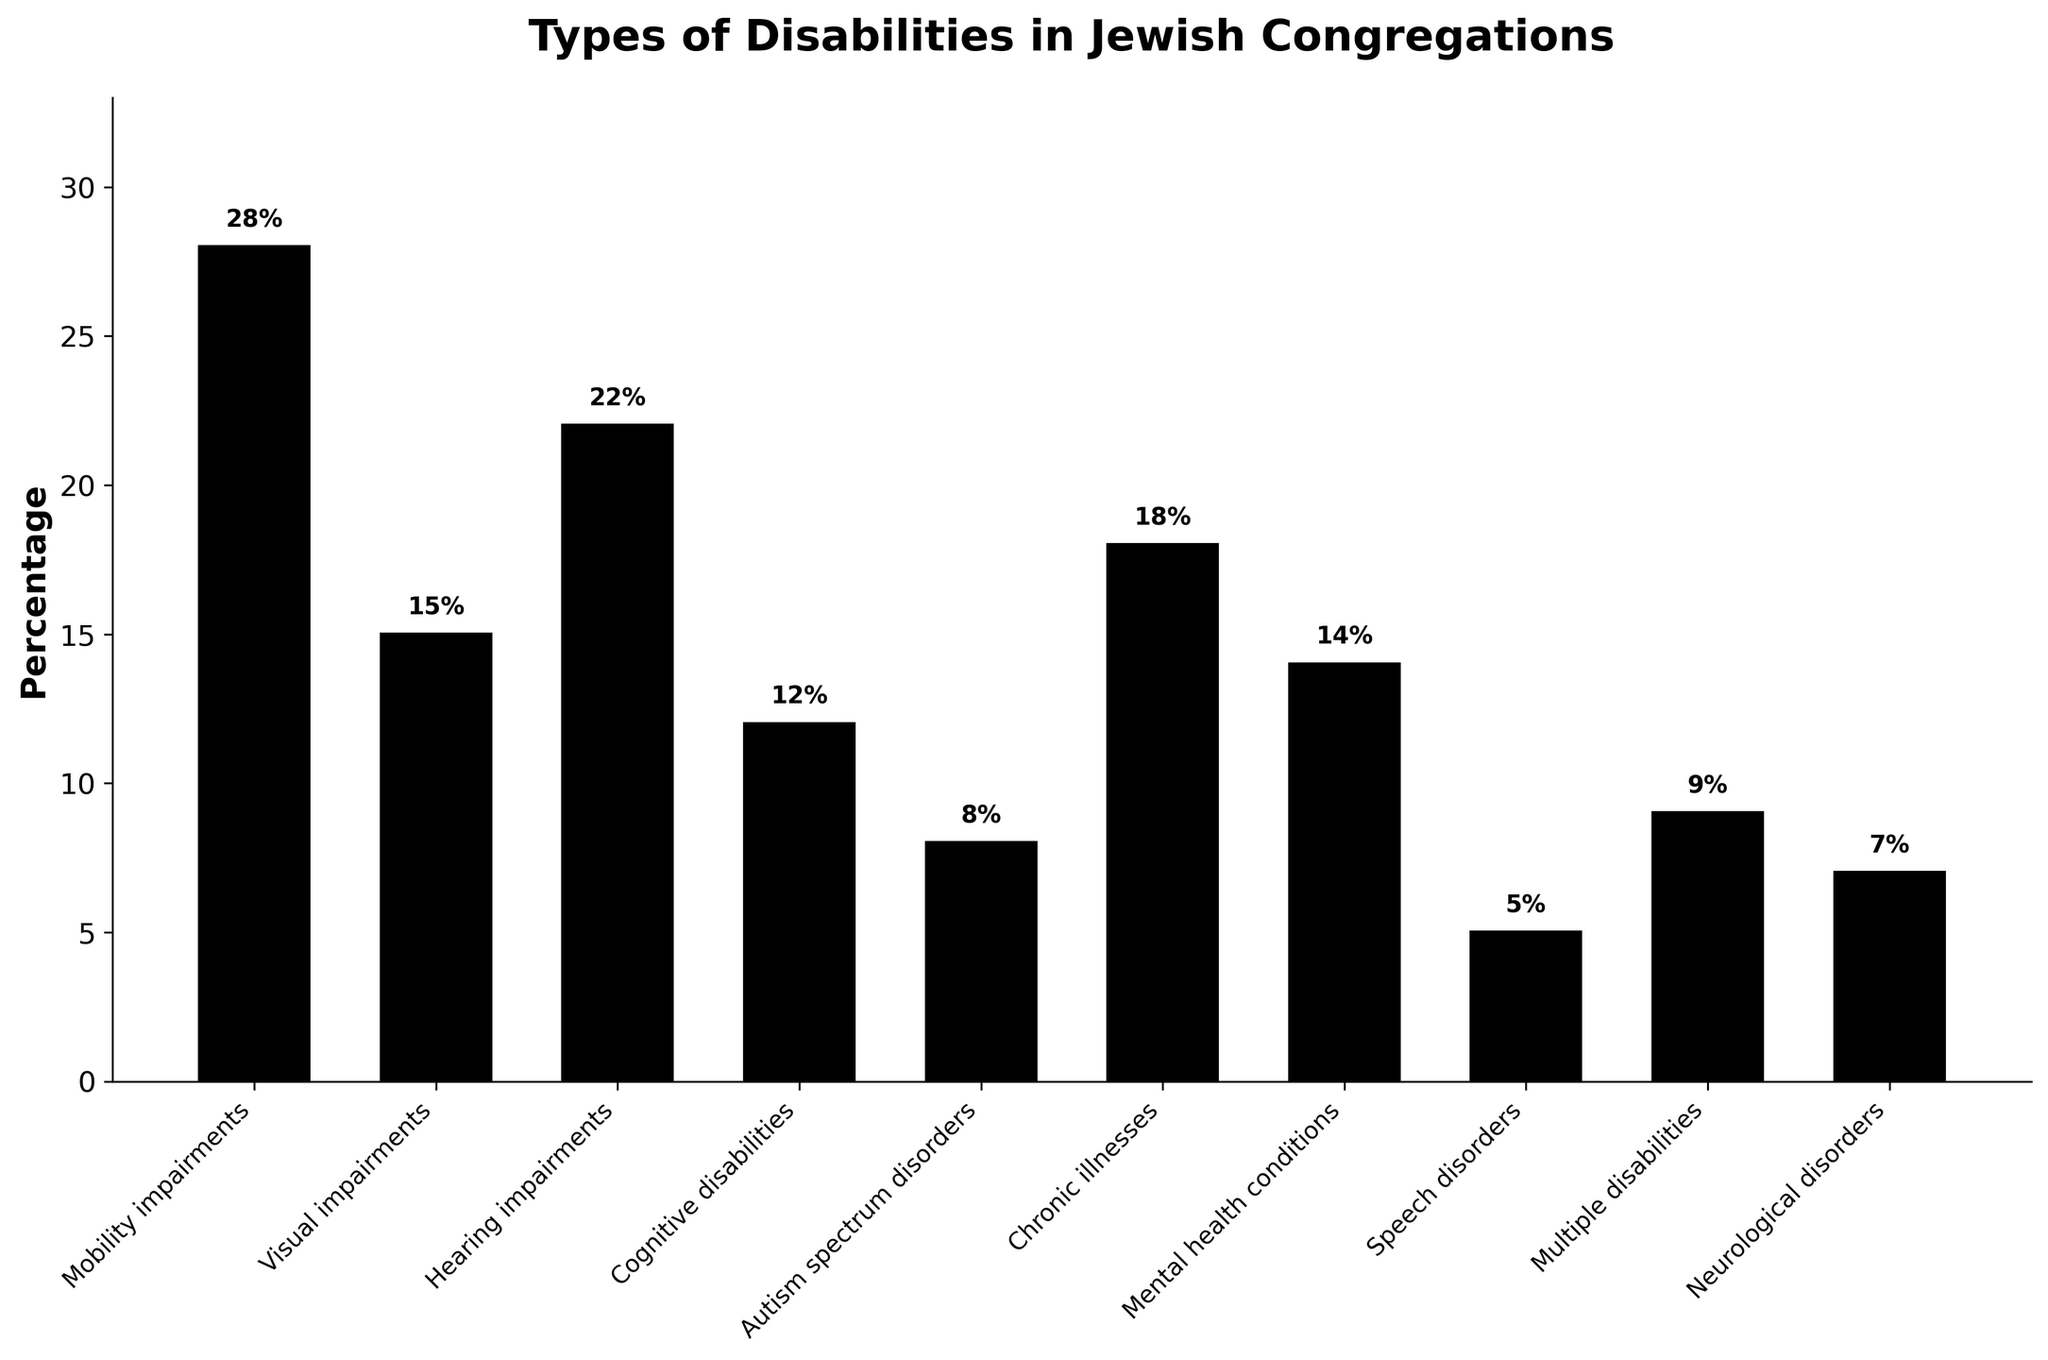What is the most common type of disability represented in Jewish congregations? The bar representing "Mobility impairments" is the tallest, indicating that it has the highest percentage.
Answer: Mobility impairments Which type of disability is less common: hearing impairments or cognitive disabilities? The bar for "Cognitive disabilities" is shorter than the bar for "Hearing impairments," indicating a lower percentage.
Answer: Cognitive disabilities How much higher is the percentage of mobility impairments compared to speech disorders? The percentage for mobility impairments is 28%, and for speech disorders, it is 5%. The difference is 28% - 5% = 23%.
Answer: 23% What is the total percentage of visual impairments, hearing impairments, and cognitive disabilities combined? Adding the percentages for visual impairments (15%), hearing impairments (22%), and cognitive disabilities (12%) gives 15% + 22% + 12% = 49%.
Answer: 49% Is the percentage of chronic illnesses higher than mental health conditions? The bar for "Chronic illnesses" is taller than the bar for "Mental health conditions," indicating a higher percentage.
Answer: Yes Which two types of disabilities have single-digit percentages and how do their percentages compare? The bars for "Autism spectrum disorders" (8%) and "Neurological disorders" (7%) are in the single-digit range. Comparing their heights, autism spectrum disorders are slightly higher.
Answer: Autism spectrum disorders are higher Among the types of disabilities with percentages below 10%, which one has the highest percentage? The types of disabilities with percentages below 10% are Autism spectrum disorders (8%), Multiple disabilities (9%), Speech disorders (5%), Neurological disorders (7%). The highest among them is "Multiple disabilities" with 9%.
Answer: Multiple disabilities What is the ratio of the percentage of mental health conditions to the percentage of visual impairments? The percentage for mental health conditions is 14%, and for visual impairments, it is 15%. The ratio is 14% / 15%.
Answer: 14:15 How many disability types have percentages above 20%? The bars above 20% are Mobility impairments (28%) and Hearing impairments (22%), so there are 2 types.
Answer: 2 What is the difference between the highest and lowest percentages of disabilities represented? The highest percentage is Mobility impairments (28%), and the lowest is Speech disorders (5%). The difference is 28% - 5% = 23%.
Answer: 23% 